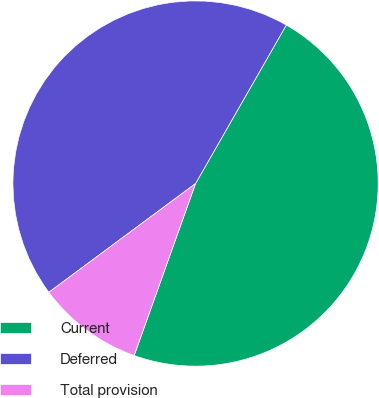Convert chart. <chart><loc_0><loc_0><loc_500><loc_500><pie_chart><fcel>Current<fcel>Deferred<fcel>Total provision<nl><fcel>47.18%<fcel>43.43%<fcel>9.39%<nl></chart> 